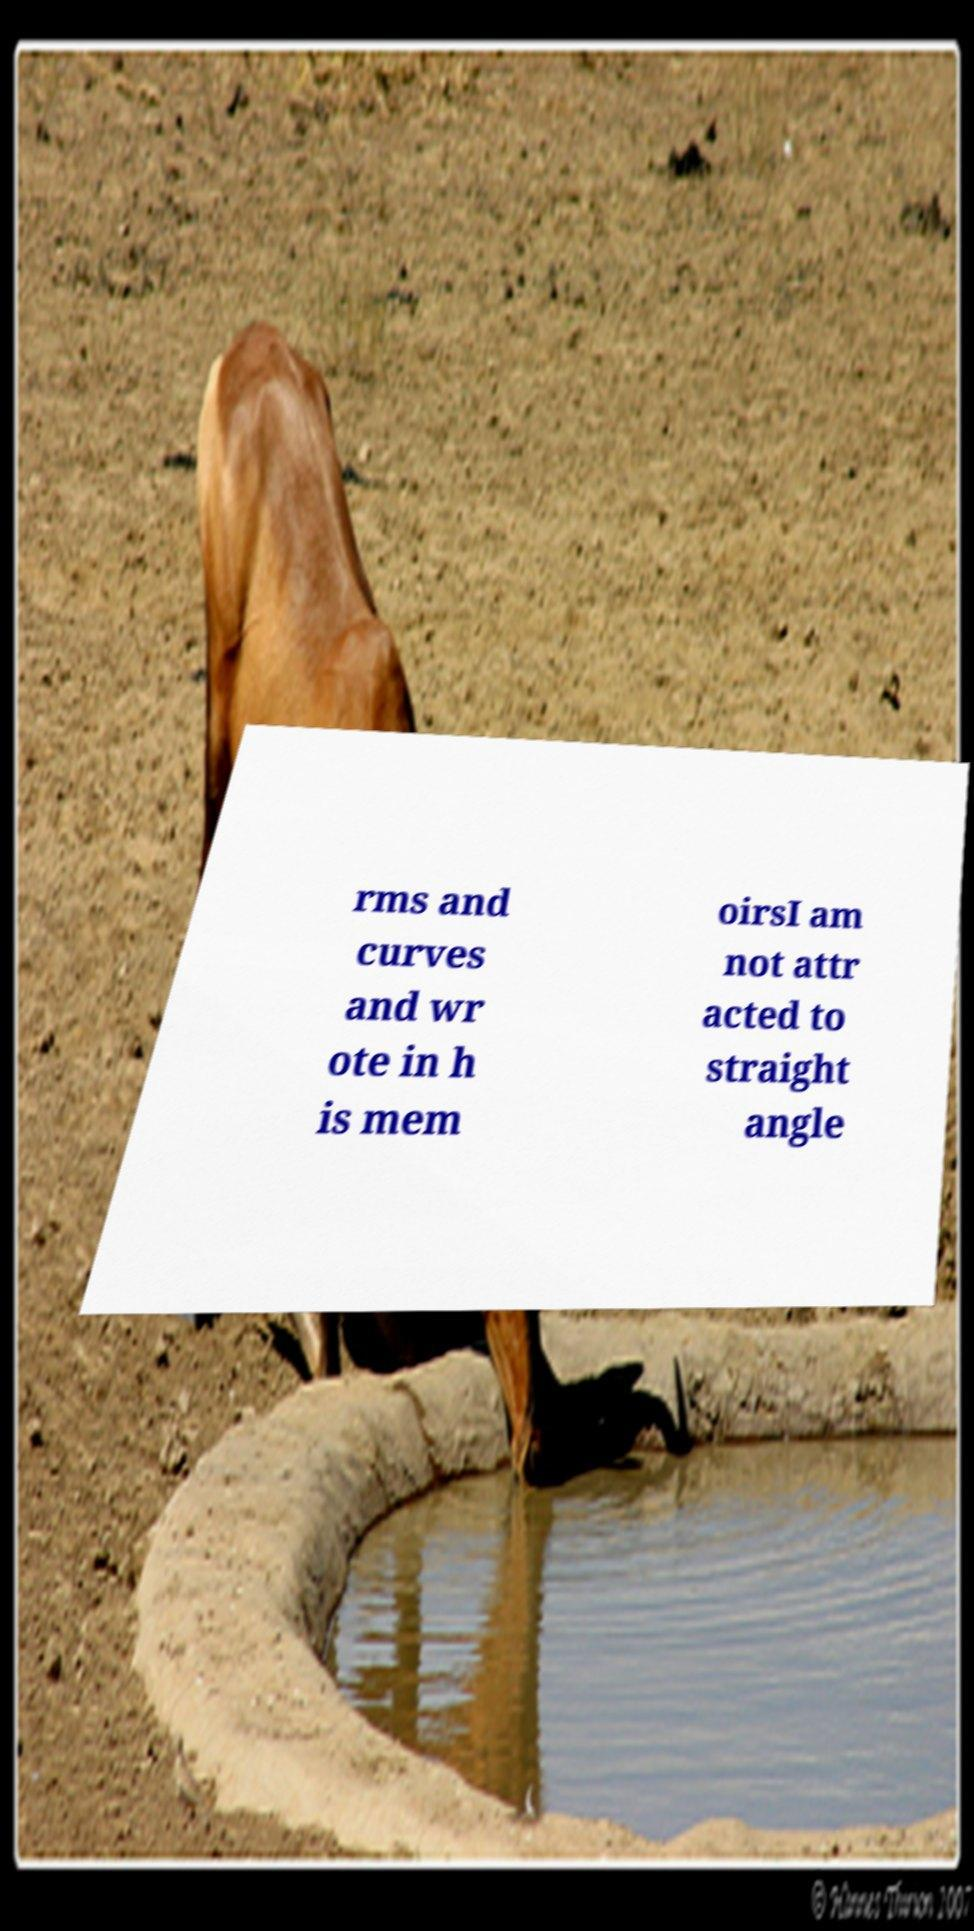Please read and relay the text visible in this image. What does it say? rms and curves and wr ote in h is mem oirsI am not attr acted to straight angle 